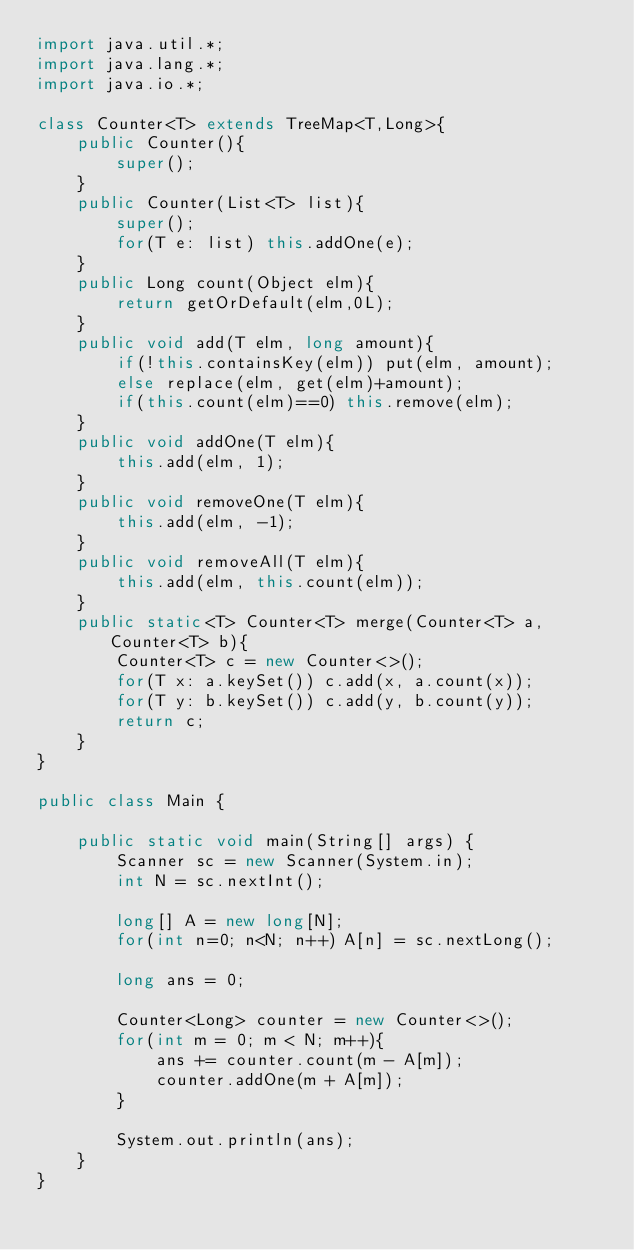<code> <loc_0><loc_0><loc_500><loc_500><_Java_>import java.util.*;
import java.lang.*;
import java.io.*;

class Counter<T> extends TreeMap<T,Long>{
    public Counter(){
        super();
    }
    public Counter(List<T> list){
        super();
        for(T e: list) this.addOne(e);
    }
    public Long count(Object elm){
        return getOrDefault(elm,0L);
    }
    public void add(T elm, long amount){
        if(!this.containsKey(elm)) put(elm, amount);
        else replace(elm, get(elm)+amount);
        if(this.count(elm)==0) this.remove(elm);
    }
    public void addOne(T elm){
        this.add(elm, 1);
    }
    public void removeOne(T elm){
        this.add(elm, -1);
    }
    public void removeAll(T elm){
        this.add(elm, this.count(elm));
    }
    public static<T> Counter<T> merge(Counter<T> a, Counter<T> b){
        Counter<T> c = new Counter<>();
        for(T x: a.keySet()) c.add(x, a.count(x));
        for(T y: b.keySet()) c.add(y, b.count(y));
        return c;
    }
}

public class Main {

    public static void main(String[] args) {
        Scanner sc = new Scanner(System.in);
        int N = sc.nextInt();

        long[] A = new long[N];
        for(int n=0; n<N; n++) A[n] = sc.nextLong();

        long ans = 0;

        Counter<Long> counter = new Counter<>();
        for(int m = 0; m < N; m++){
            ans += counter.count(m - A[m]);
            counter.addOne(m + A[m]);
        }
        
        System.out.println(ans);
    }
}
</code> 